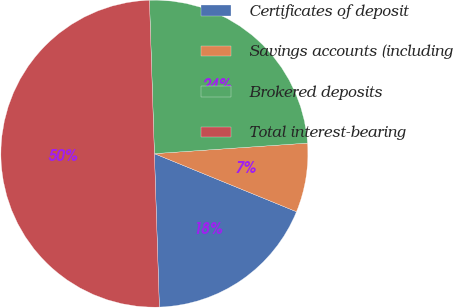Convert chart. <chart><loc_0><loc_0><loc_500><loc_500><pie_chart><fcel>Certificates of deposit<fcel>Savings accounts (including<fcel>Brokered deposits<fcel>Total interest-bearing<nl><fcel>18.31%<fcel>7.27%<fcel>24.42%<fcel>50.0%<nl></chart> 